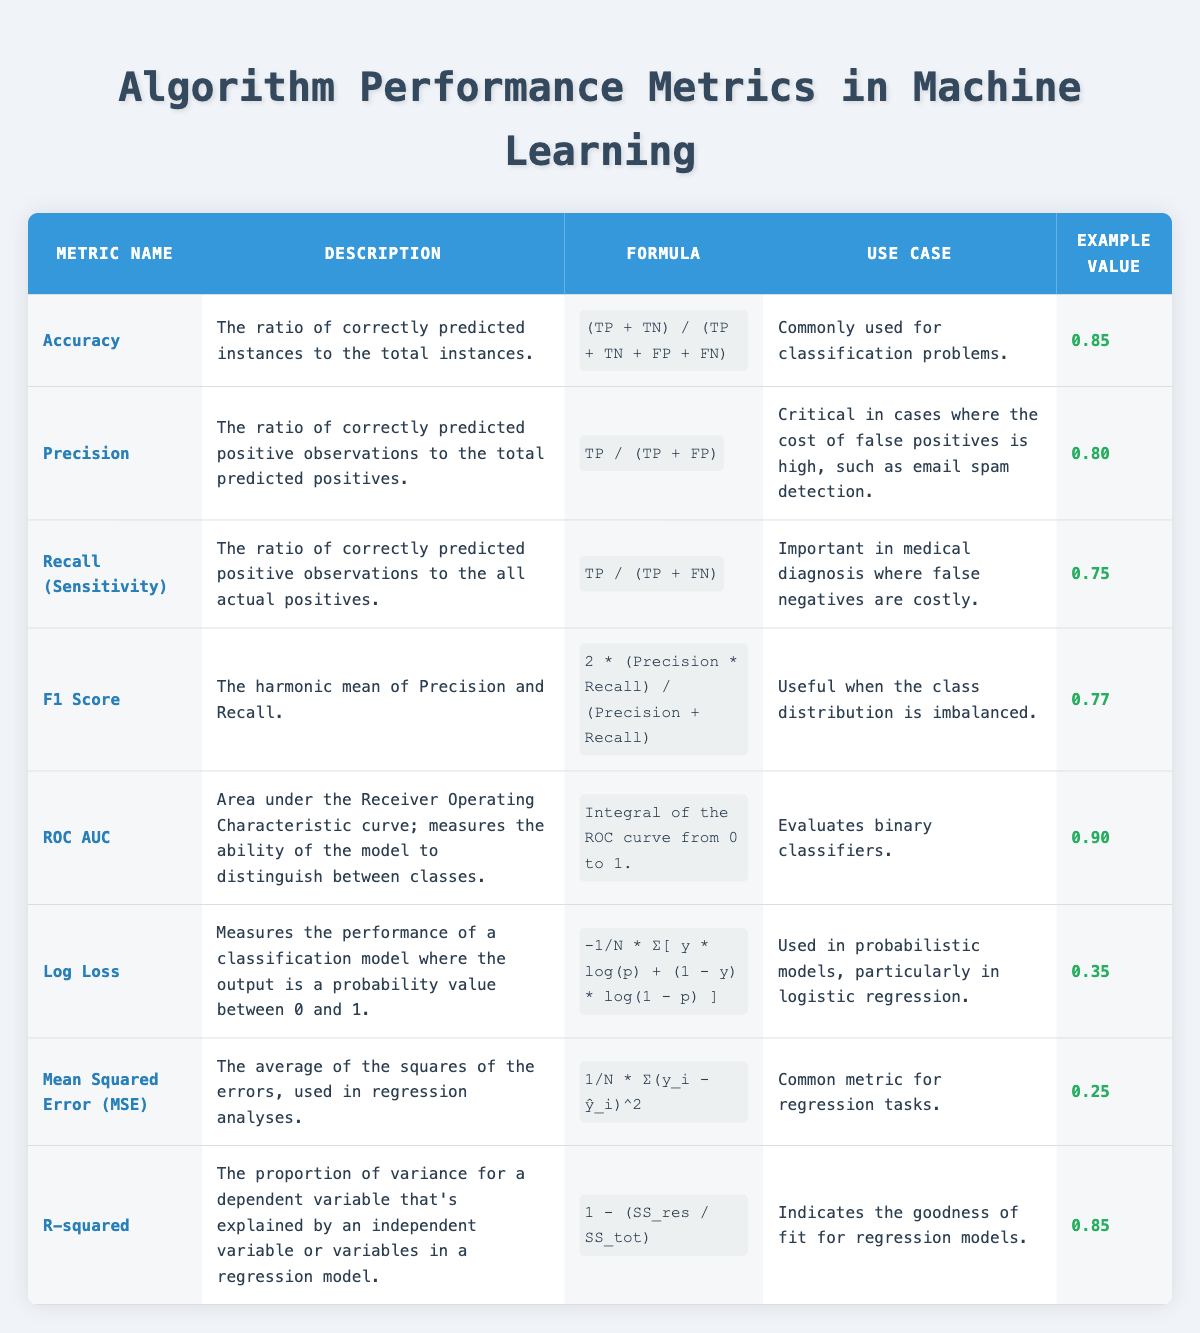What is the description of the F1 Score metric? The table specifies that the F1 Score is described as "The harmonic mean of Precision and Recall."
Answer: The harmonic mean of Precision and Recall What metric measures the performance of a classification model where the output is a probability value? According to the table, the metric that measures the performance of such a model is "Log Loss."
Answer: Log Loss What is the formula for calculating Precision? From the table, the formula for Precision is given as "TP / (TP + FP)."
Answer: TP / (TP + FP) Is Accuracy the only metric commonly used for classification problems? The table only mentions Accuracy as commonly used for classification, but other metrics like Precision, Recall, and F1 Score can also be relevant in classification problems.
Answer: No What is the average example value of the metrics listed in the table? To find the average value, add all example values: 0.85 + 0.80 + 0.75 + 0.77 + 0.90 + 0.35 + 0.25 + 0.85 = 5.67. Since there are 8 metrics, the average is 5.67 / 8 = 0.70875.
Answer: 0.71 Which metric has the highest example value and what is that value? By reviewing the example values, ROC AUC has the highest example value of 0.90.
Answer: 0.90 If a model has a Recall of 0.75, what does this imply about its performance in medical diagnosis? A Recall of 0.75 indicates that the model correctly identifies 75% of actual positive cases, hence it is fairly effective in a context like medical diagnosis where missing positive cases can be costly.
Answer: It is effective How would you describe the use case of the Log Loss metric? The table indicates that Log Loss is used in probabilistic models, particularly in logistic regression, which relates to performance measurement across a probability scale.
Answer: In probabilistic models, especially logistic regression Is the formula for R-squared used to indicate the goodness of fit for regression models? Yes, the description explicitly states that R-squared indicates the goodness of fit in regression models, confirming its role in model evaluation.
Answer: Yes 